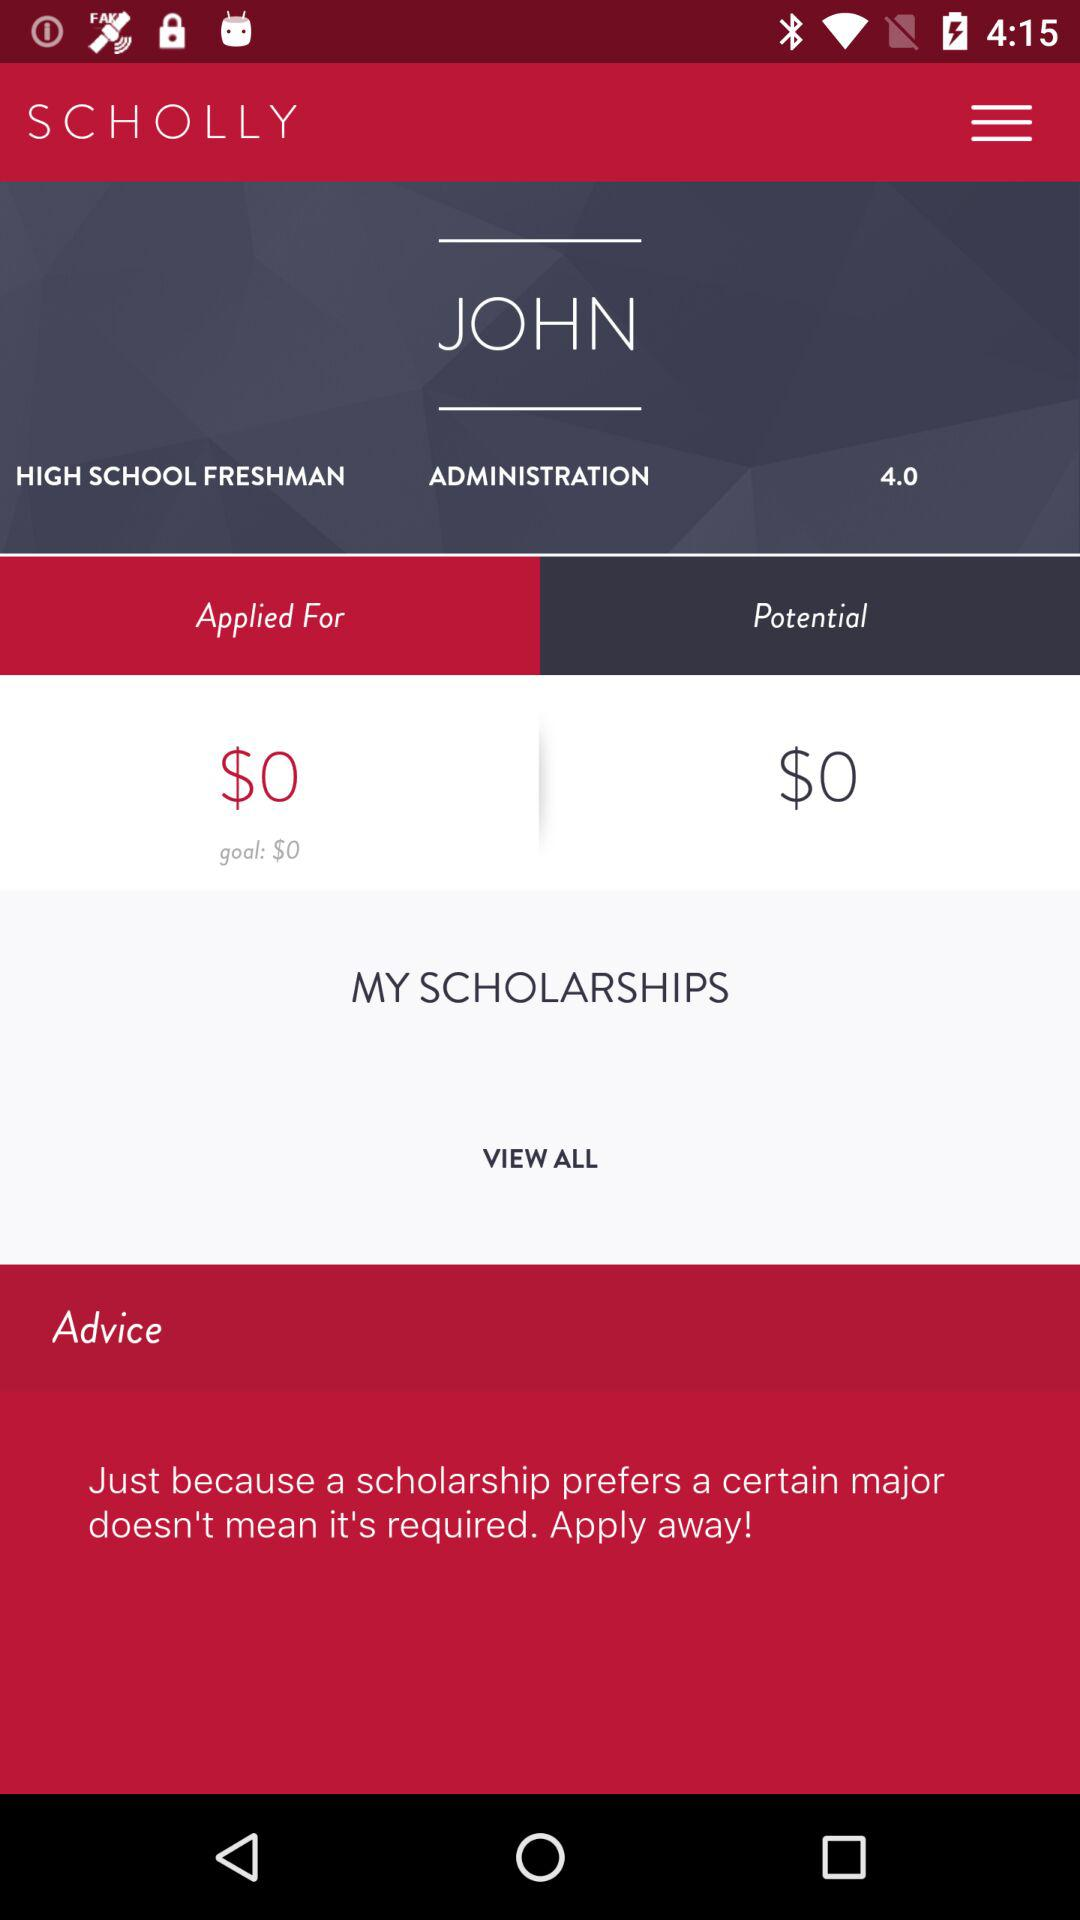What is the name of the School?
When the provided information is insufficient, respond with <no answer>. <no answer> 